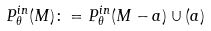Convert formula to latex. <formula><loc_0><loc_0><loc_500><loc_500>P _ { \theta } ^ { i n } ( M ) \colon = P _ { \theta } ^ { i n } ( M - a ) \cup { ( a ) }</formula> 